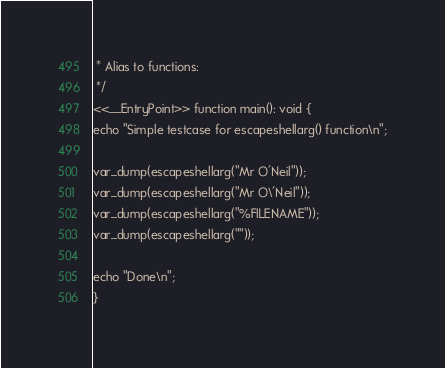<code> <loc_0><loc_0><loc_500><loc_500><_PHP_> * Alias to functions: 
 */
<<__EntryPoint>> function main(): void {
echo "Simple testcase for escapeshellarg() function\n";

var_dump(escapeshellarg("Mr O'Neil"));
var_dump(escapeshellarg("Mr O\'Neil"));
var_dump(escapeshellarg("%FILENAME"));
var_dump(escapeshellarg(""));

echo "Done\n";
}
</code> 